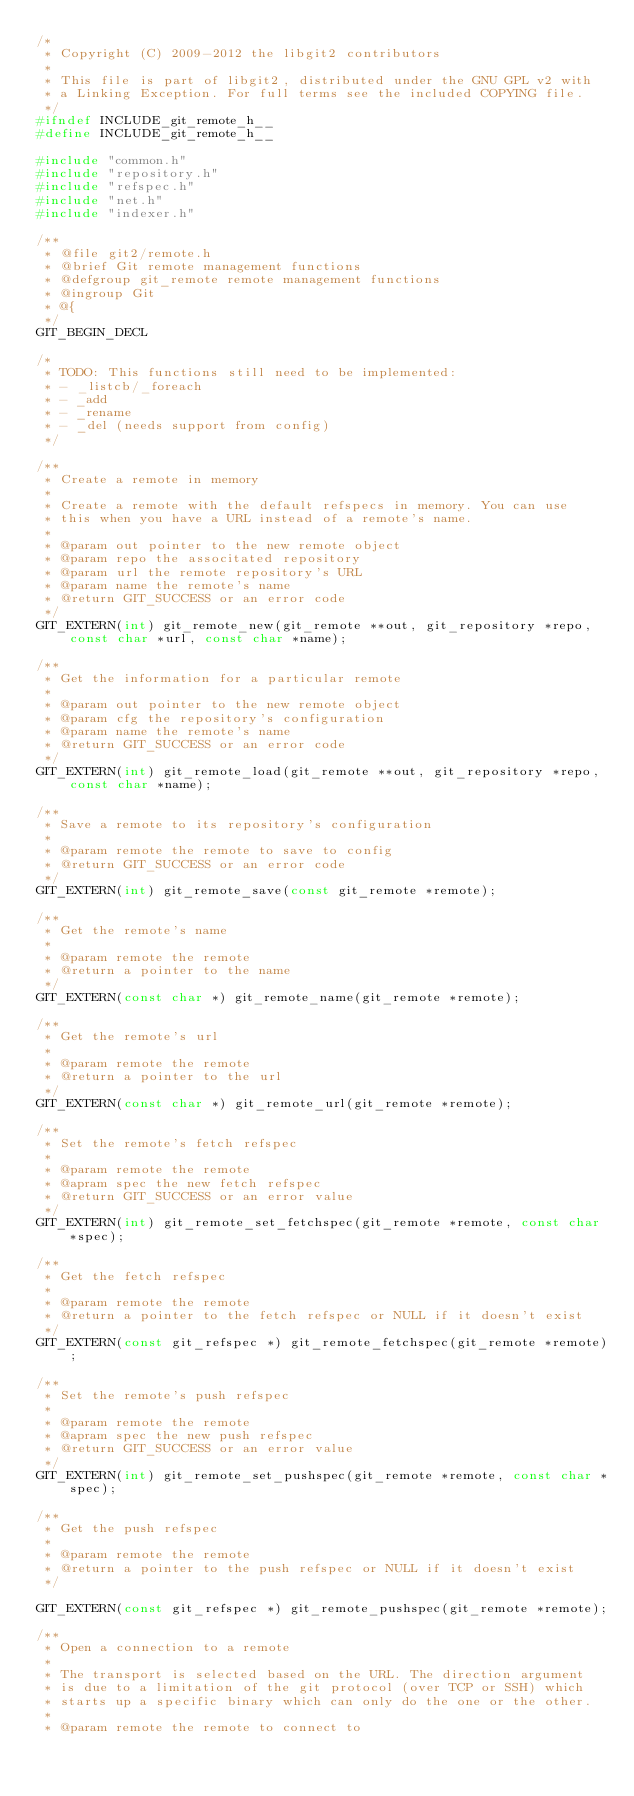Convert code to text. <code><loc_0><loc_0><loc_500><loc_500><_C_>/*
 * Copyright (C) 2009-2012 the libgit2 contributors
 *
 * This file is part of libgit2, distributed under the GNU GPL v2 with
 * a Linking Exception. For full terms see the included COPYING file.
 */
#ifndef INCLUDE_git_remote_h__
#define INCLUDE_git_remote_h__

#include "common.h"
#include "repository.h"
#include "refspec.h"
#include "net.h"
#include "indexer.h"

/**
 * @file git2/remote.h
 * @brief Git remote management functions
 * @defgroup git_remote remote management functions
 * @ingroup Git
 * @{
 */
GIT_BEGIN_DECL

/*
 * TODO: This functions still need to be implemented:
 * - _listcb/_foreach
 * - _add
 * - _rename
 * - _del (needs support from config)
 */

/**
 * Create a remote in memory
 *
 * Create a remote with the default refspecs in memory. You can use
 * this when you have a URL instead of a remote's name.
 *
 * @param out pointer to the new remote object
 * @param repo the associtated repository
 * @param url the remote repository's URL
 * @param name the remote's name
 * @return GIT_SUCCESS or an error code
 */
GIT_EXTERN(int) git_remote_new(git_remote **out, git_repository *repo, const char *url, const char *name);

/**
 * Get the information for a particular remote
 *
 * @param out pointer to the new remote object
 * @param cfg the repository's configuration
 * @param name the remote's name
 * @return GIT_SUCCESS or an error code
 */
GIT_EXTERN(int) git_remote_load(git_remote **out, git_repository *repo, const char *name);

/**
 * Save a remote to its repository's configuration
 *
 * @param remote the remote to save to config
 * @return GIT_SUCCESS or an error code
 */
GIT_EXTERN(int) git_remote_save(const git_remote *remote);

/**
 * Get the remote's name
 *
 * @param remote the remote
 * @return a pointer to the name
 */
GIT_EXTERN(const char *) git_remote_name(git_remote *remote);

/**
 * Get the remote's url
 *
 * @param remote the remote
 * @return a pointer to the url
 */
GIT_EXTERN(const char *) git_remote_url(git_remote *remote);

/**
 * Set the remote's fetch refspec
 *
 * @param remote the remote
 * @apram spec the new fetch refspec
 * @return GIT_SUCCESS or an error value
 */
GIT_EXTERN(int) git_remote_set_fetchspec(git_remote *remote, const char *spec);

/**
 * Get the fetch refspec
 *
 * @param remote the remote
 * @return a pointer to the fetch refspec or NULL if it doesn't exist
 */
GIT_EXTERN(const git_refspec *) git_remote_fetchspec(git_remote *remote);

/**
 * Set the remote's push refspec
 *
 * @param remote the remote
 * @apram spec the new push refspec
 * @return GIT_SUCCESS or an error value
 */
GIT_EXTERN(int) git_remote_set_pushspec(git_remote *remote, const char *spec);

/**
 * Get the push refspec
 *
 * @param remote the remote
 * @return a pointer to the push refspec or NULL if it doesn't exist
 */

GIT_EXTERN(const git_refspec *) git_remote_pushspec(git_remote *remote);

/**
 * Open a connection to a remote
 *
 * The transport is selected based on the URL. The direction argument
 * is due to a limitation of the git protocol (over TCP or SSH) which
 * starts up a specific binary which can only do the one or the other.
 *
 * @param remote the remote to connect to</code> 